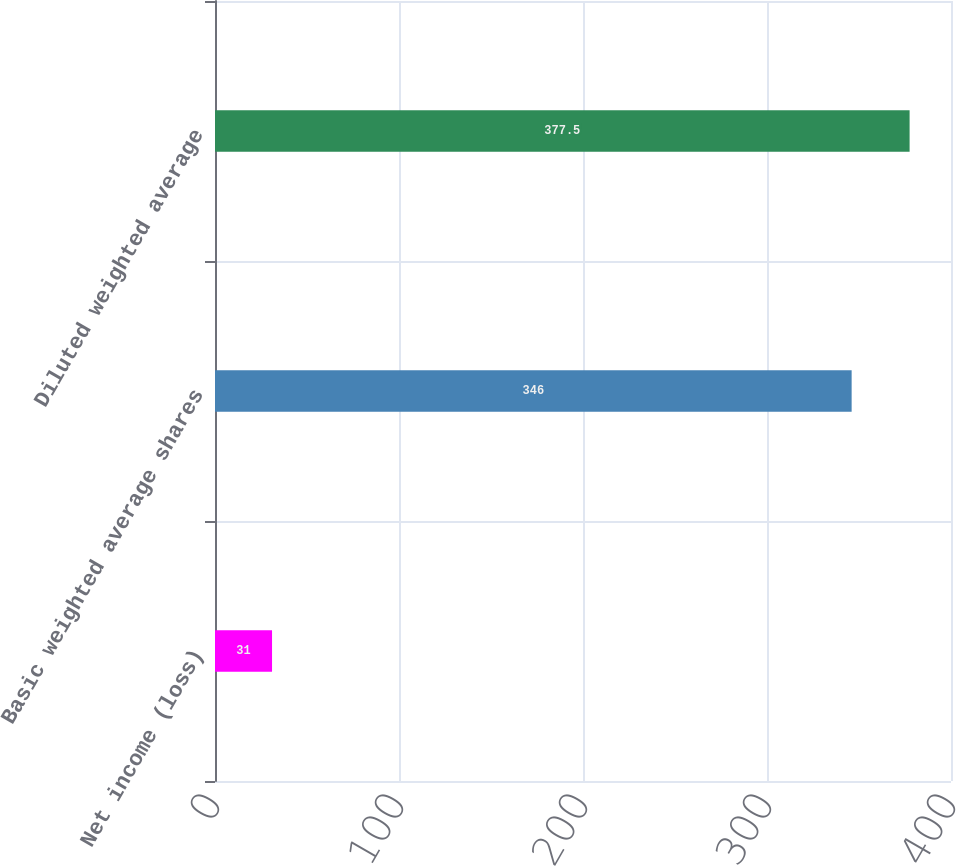<chart> <loc_0><loc_0><loc_500><loc_500><bar_chart><fcel>Net income (loss)<fcel>Basic weighted average shares<fcel>Diluted weighted average<nl><fcel>31<fcel>346<fcel>377.5<nl></chart> 